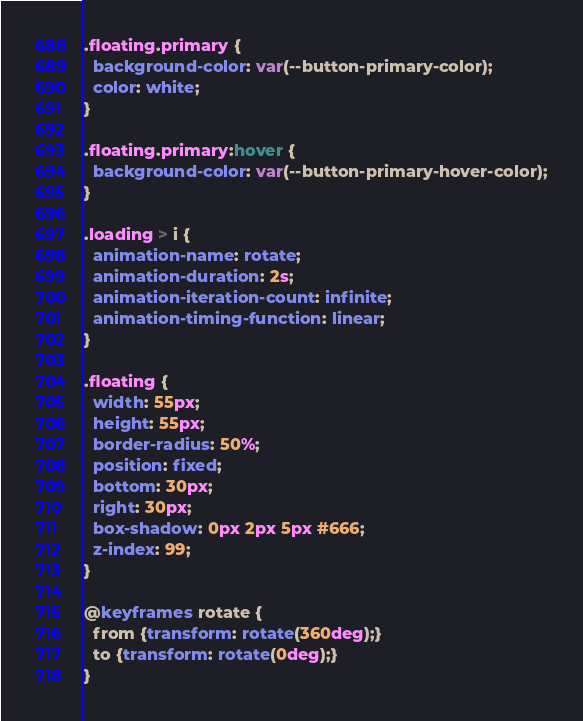<code> <loc_0><loc_0><loc_500><loc_500><_CSS_>.floating.primary {
  background-color: var(--button-primary-color);
  color: white;
}

.floating.primary:hover {
  background-color: var(--button-primary-hover-color);
}

.loading > i {
  animation-name: rotate; 
  animation-duration: 2s; 
  animation-iteration-count: infinite;
  animation-timing-function: linear;
}

.floating {
  width: 55px;
  height: 55px;
  border-radius: 50%;
  position: fixed;
  bottom: 30px;
  right: 30px;
  box-shadow: 0px 2px 5px #666;
  z-index: 99;
}

@keyframes rotate {
  from {transform: rotate(360deg);}
  to {transform: rotate(0deg);}
}
</code> 